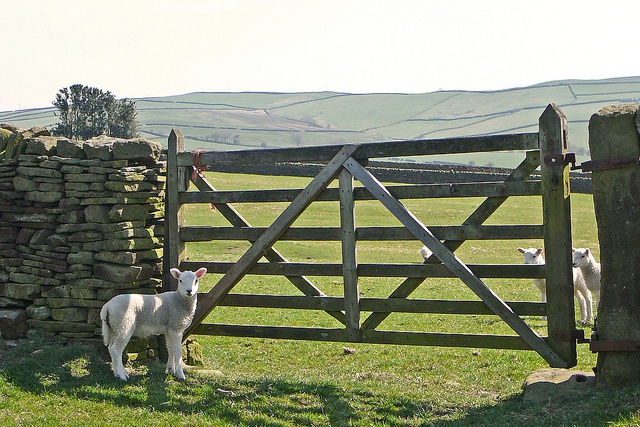Describe the objects in this image and their specific colors. I can see sheep in ivory, gray, and darkgray tones, sheep in ivory, white, darkgray, and gray tones, sheep in ivory, gray, darkgray, and white tones, and sheep in ivory, darkgray, gray, and tan tones in this image. 